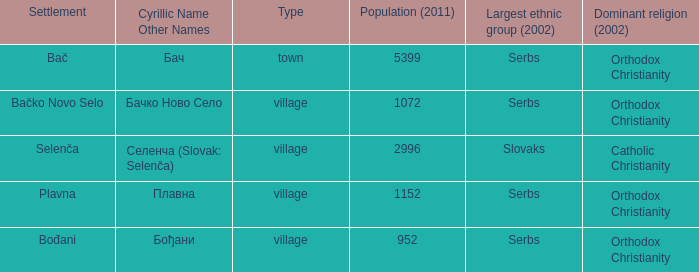What is the smallest population listed? 952.0. 